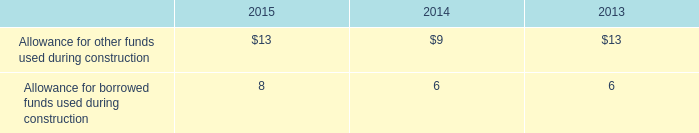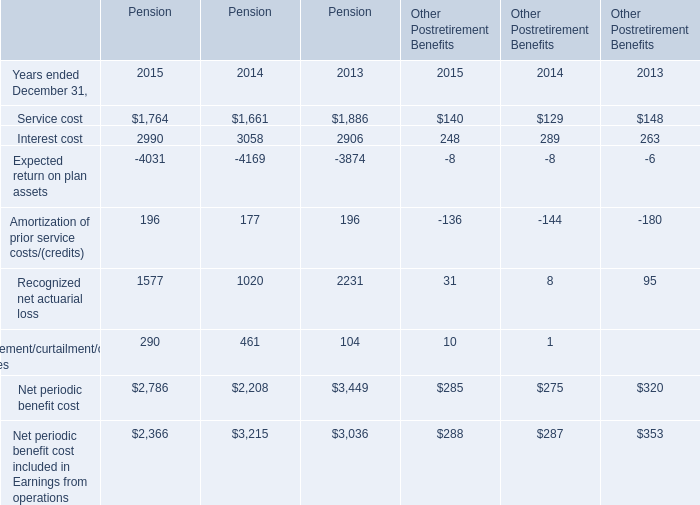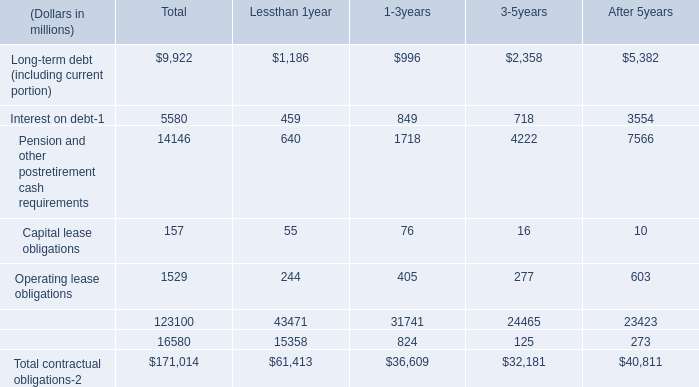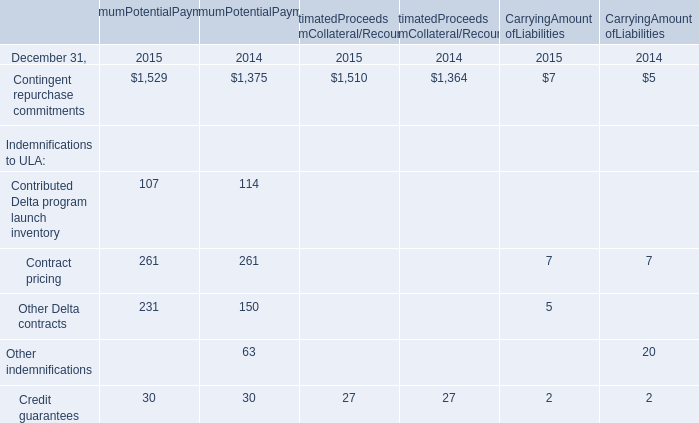What is the total amount of Net periodic benefit cost of Pension 2013, Contingent repurchase commitments of MaximumPotentialPayments 2015, and Expected return on plan assets of Pension 2015 ? 
Computations: ((3449.0 + 1529.0) + 4031.0)
Answer: 9009.0. 